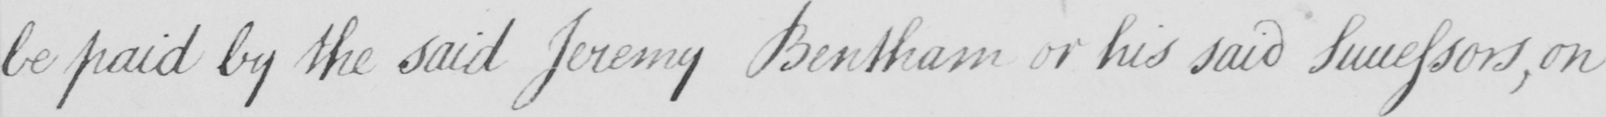Please provide the text content of this handwritten line. be paid by the said Jeremy Bentham or his said Successors , on 